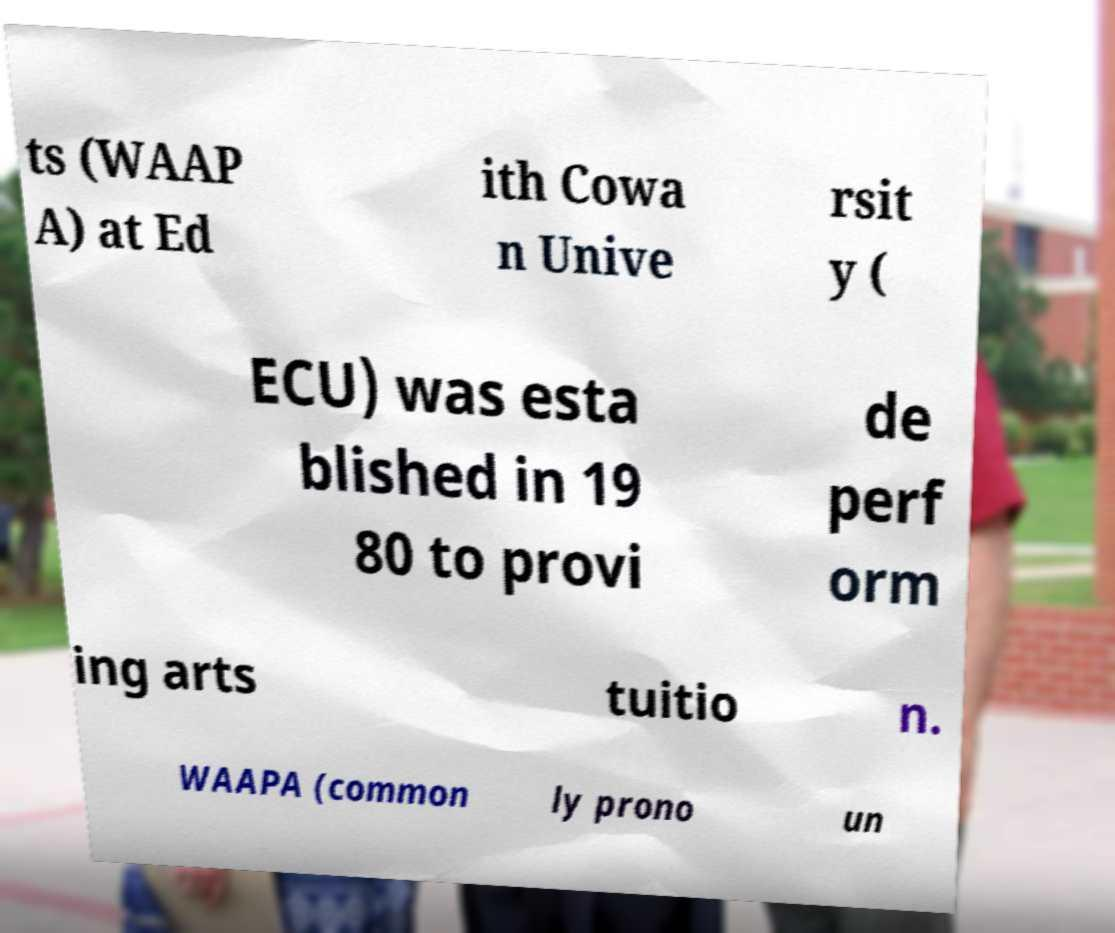I need the written content from this picture converted into text. Can you do that? ts (WAAP A) at Ed ith Cowa n Unive rsit y ( ECU) was esta blished in 19 80 to provi de perf orm ing arts tuitio n. WAAPA (common ly prono un 